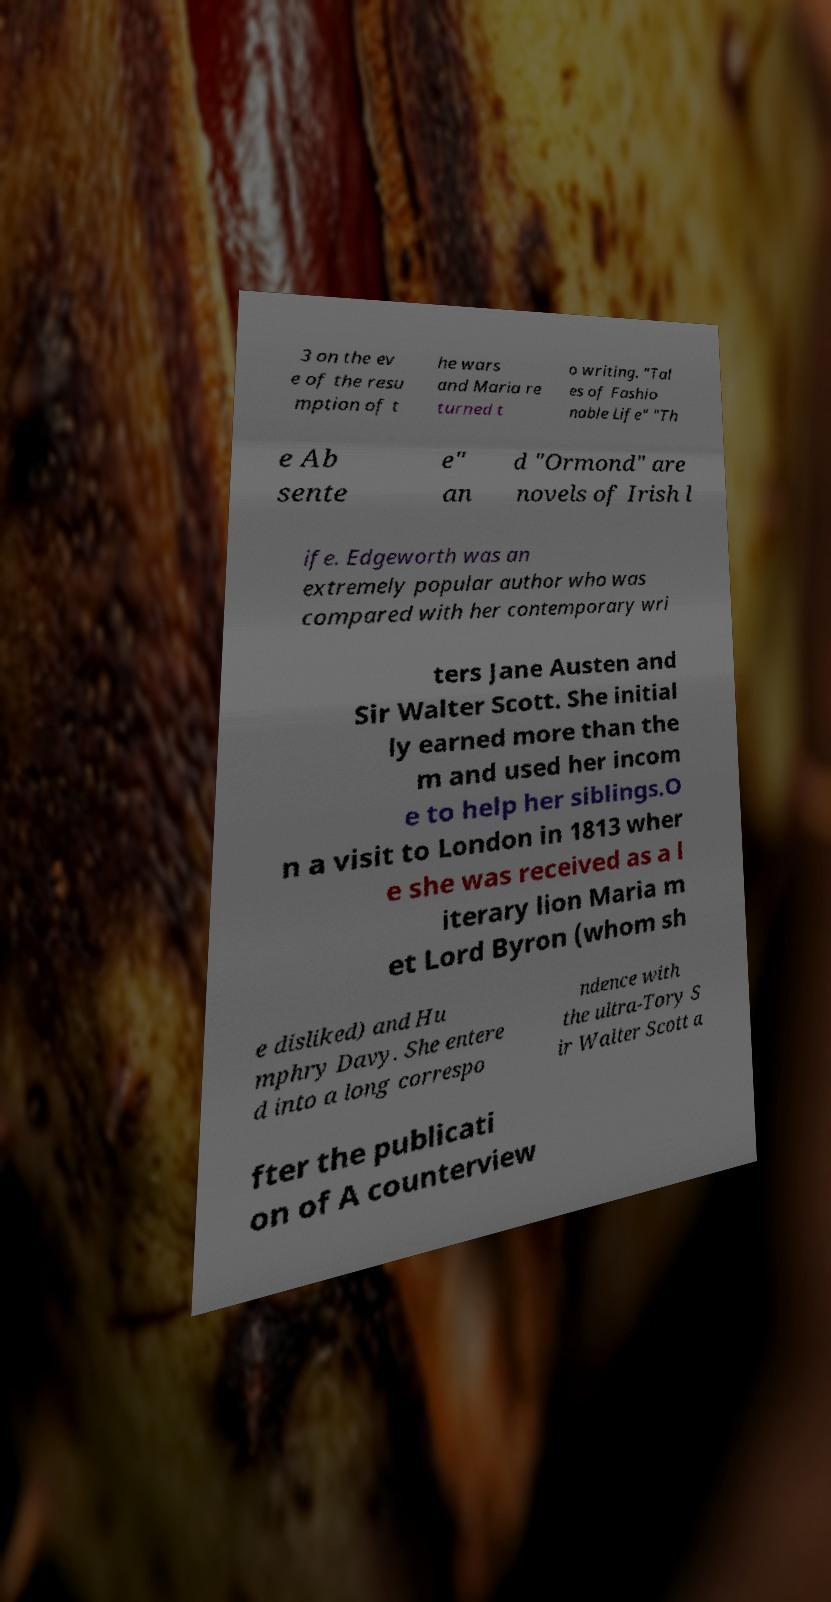For documentation purposes, I need the text within this image transcribed. Could you provide that? 3 on the ev e of the resu mption of t he wars and Maria re turned t o writing. "Tal es of Fashio nable Life" "Th e Ab sente e" an d "Ormond" are novels of Irish l ife. Edgeworth was an extremely popular author who was compared with her contemporary wri ters Jane Austen and Sir Walter Scott. She initial ly earned more than the m and used her incom e to help her siblings.O n a visit to London in 1813 wher e she was received as a l iterary lion Maria m et Lord Byron (whom sh e disliked) and Hu mphry Davy. She entere d into a long correspo ndence with the ultra-Tory S ir Walter Scott a fter the publicati on of A counterview 